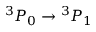Convert formula to latex. <formula><loc_0><loc_0><loc_500><loc_500>{ } ^ { 3 } P _ { 0 } ^ { 3 } P _ { 1 }</formula> 